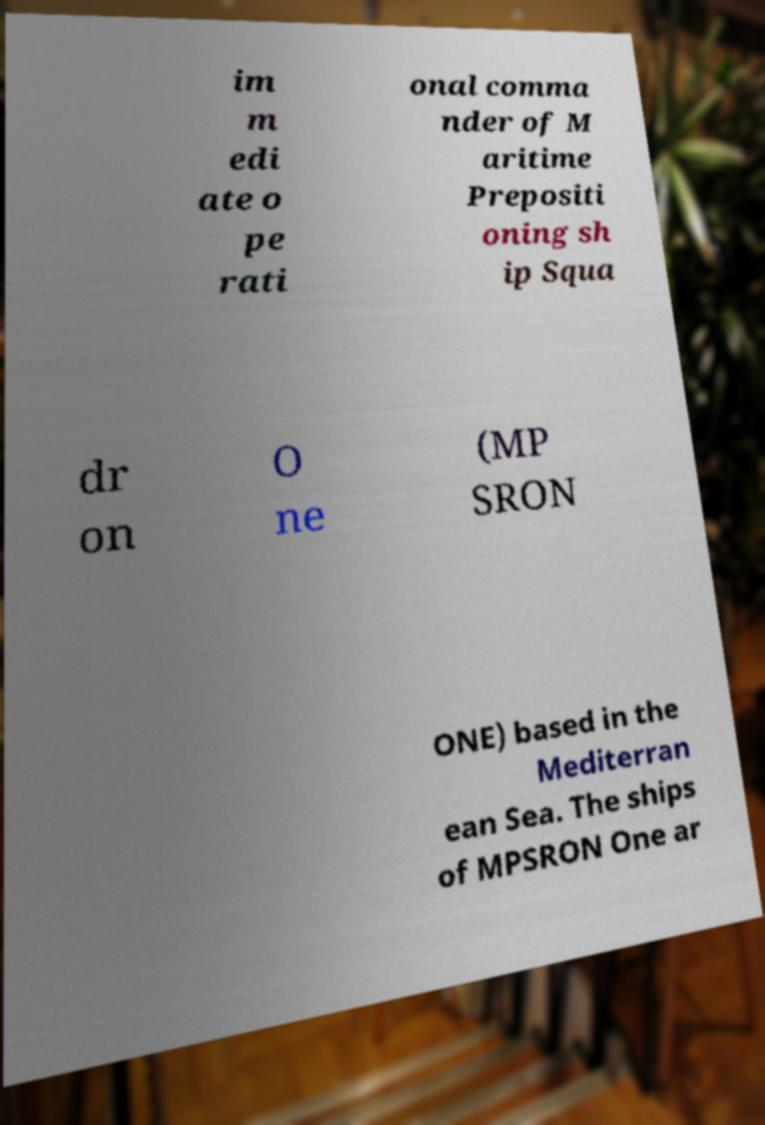Can you read and provide the text displayed in the image?This photo seems to have some interesting text. Can you extract and type it out for me? im m edi ate o pe rati onal comma nder of M aritime Prepositi oning sh ip Squa dr on O ne (MP SRON ONE) based in the Mediterran ean Sea. The ships of MPSRON One ar 